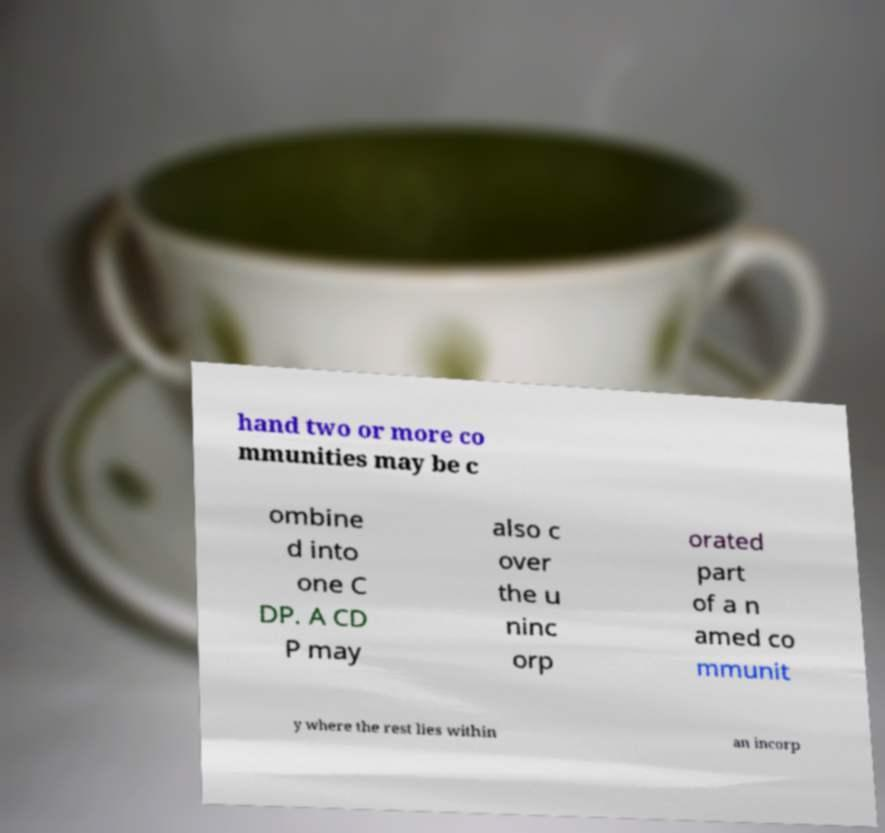Could you extract and type out the text from this image? hand two or more co mmunities may be c ombine d into one C DP. A CD P may also c over the u ninc orp orated part of a n amed co mmunit y where the rest lies within an incorp 